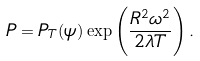<formula> <loc_0><loc_0><loc_500><loc_500>P = P _ { T } ( \psi ) \exp \left ( \frac { R ^ { 2 } \omega ^ { 2 } } { 2 \lambda T } \right ) .</formula> 